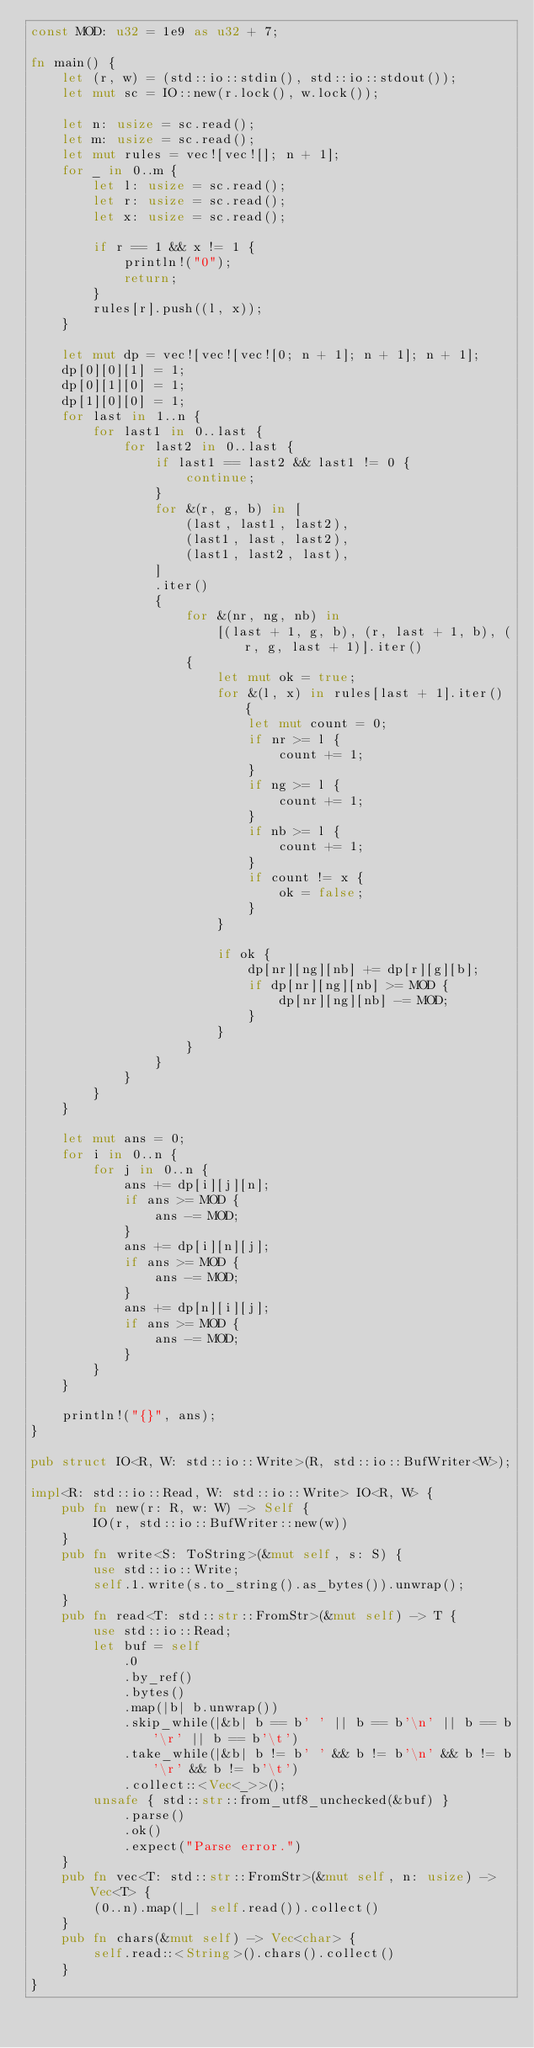<code> <loc_0><loc_0><loc_500><loc_500><_Rust_>const MOD: u32 = 1e9 as u32 + 7;

fn main() {
    let (r, w) = (std::io::stdin(), std::io::stdout());
    let mut sc = IO::new(r.lock(), w.lock());

    let n: usize = sc.read();
    let m: usize = sc.read();
    let mut rules = vec![vec![]; n + 1];
    for _ in 0..m {
        let l: usize = sc.read();
        let r: usize = sc.read();
        let x: usize = sc.read();

        if r == 1 && x != 1 {
            println!("0");
            return;
        }
        rules[r].push((l, x));
    }

    let mut dp = vec![vec![vec![0; n + 1]; n + 1]; n + 1];
    dp[0][0][1] = 1;
    dp[0][1][0] = 1;
    dp[1][0][0] = 1;
    for last in 1..n {
        for last1 in 0..last {
            for last2 in 0..last {
                if last1 == last2 && last1 != 0 {
                    continue;
                }
                for &(r, g, b) in [
                    (last, last1, last2),
                    (last1, last, last2),
                    (last1, last2, last),
                ]
                .iter()
                {
                    for &(nr, ng, nb) in
                        [(last + 1, g, b), (r, last + 1, b), (r, g, last + 1)].iter()
                    {
                        let mut ok = true;
                        for &(l, x) in rules[last + 1].iter() {
                            let mut count = 0;
                            if nr >= l {
                                count += 1;
                            }
                            if ng >= l {
                                count += 1;
                            }
                            if nb >= l {
                                count += 1;
                            }
                            if count != x {
                                ok = false;
                            }
                        }

                        if ok {
                            dp[nr][ng][nb] += dp[r][g][b];
                            if dp[nr][ng][nb] >= MOD {
                                dp[nr][ng][nb] -= MOD;
                            }
                        }
                    }
                }
            }
        }
    }

    let mut ans = 0;
    for i in 0..n {
        for j in 0..n {
            ans += dp[i][j][n];
            if ans >= MOD {
                ans -= MOD;
            }
            ans += dp[i][n][j];
            if ans >= MOD {
                ans -= MOD;
            }
            ans += dp[n][i][j];
            if ans >= MOD {
                ans -= MOD;
            }
        }
    }

    println!("{}", ans);
}

pub struct IO<R, W: std::io::Write>(R, std::io::BufWriter<W>);

impl<R: std::io::Read, W: std::io::Write> IO<R, W> {
    pub fn new(r: R, w: W) -> Self {
        IO(r, std::io::BufWriter::new(w))
    }
    pub fn write<S: ToString>(&mut self, s: S) {
        use std::io::Write;
        self.1.write(s.to_string().as_bytes()).unwrap();
    }
    pub fn read<T: std::str::FromStr>(&mut self) -> T {
        use std::io::Read;
        let buf = self
            .0
            .by_ref()
            .bytes()
            .map(|b| b.unwrap())
            .skip_while(|&b| b == b' ' || b == b'\n' || b == b'\r' || b == b'\t')
            .take_while(|&b| b != b' ' && b != b'\n' && b != b'\r' && b != b'\t')
            .collect::<Vec<_>>();
        unsafe { std::str::from_utf8_unchecked(&buf) }
            .parse()
            .ok()
            .expect("Parse error.")
    }
    pub fn vec<T: std::str::FromStr>(&mut self, n: usize) -> Vec<T> {
        (0..n).map(|_| self.read()).collect()
    }
    pub fn chars(&mut self) -> Vec<char> {
        self.read::<String>().chars().collect()
    }
}
</code> 